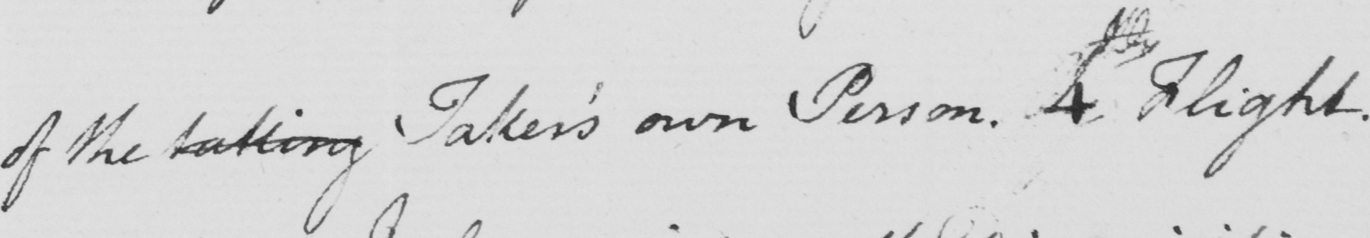Please transcribe the handwritten text in this image. of the taking Taker ' s own Person . 4th Flight . 